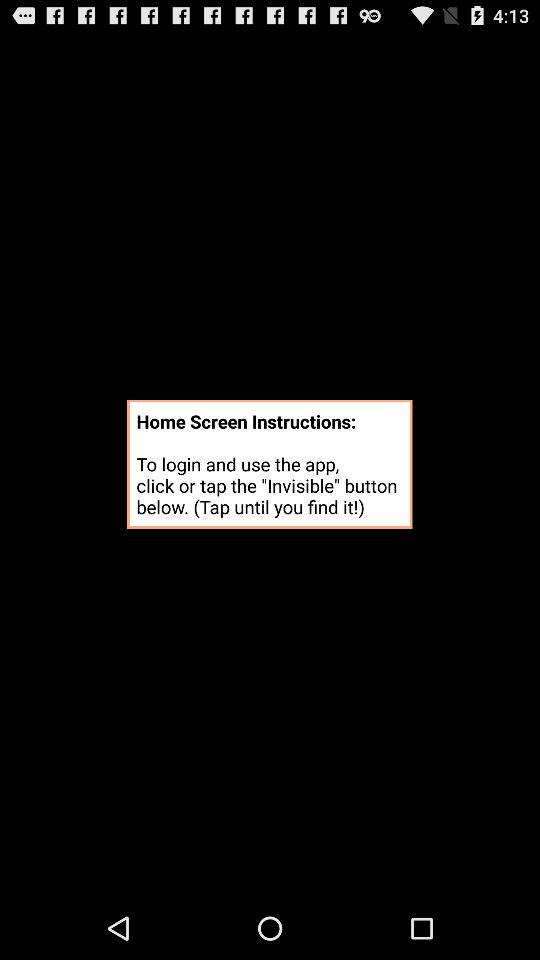What button can we click to log in and use the app? You can click on the "Invisible" button. 